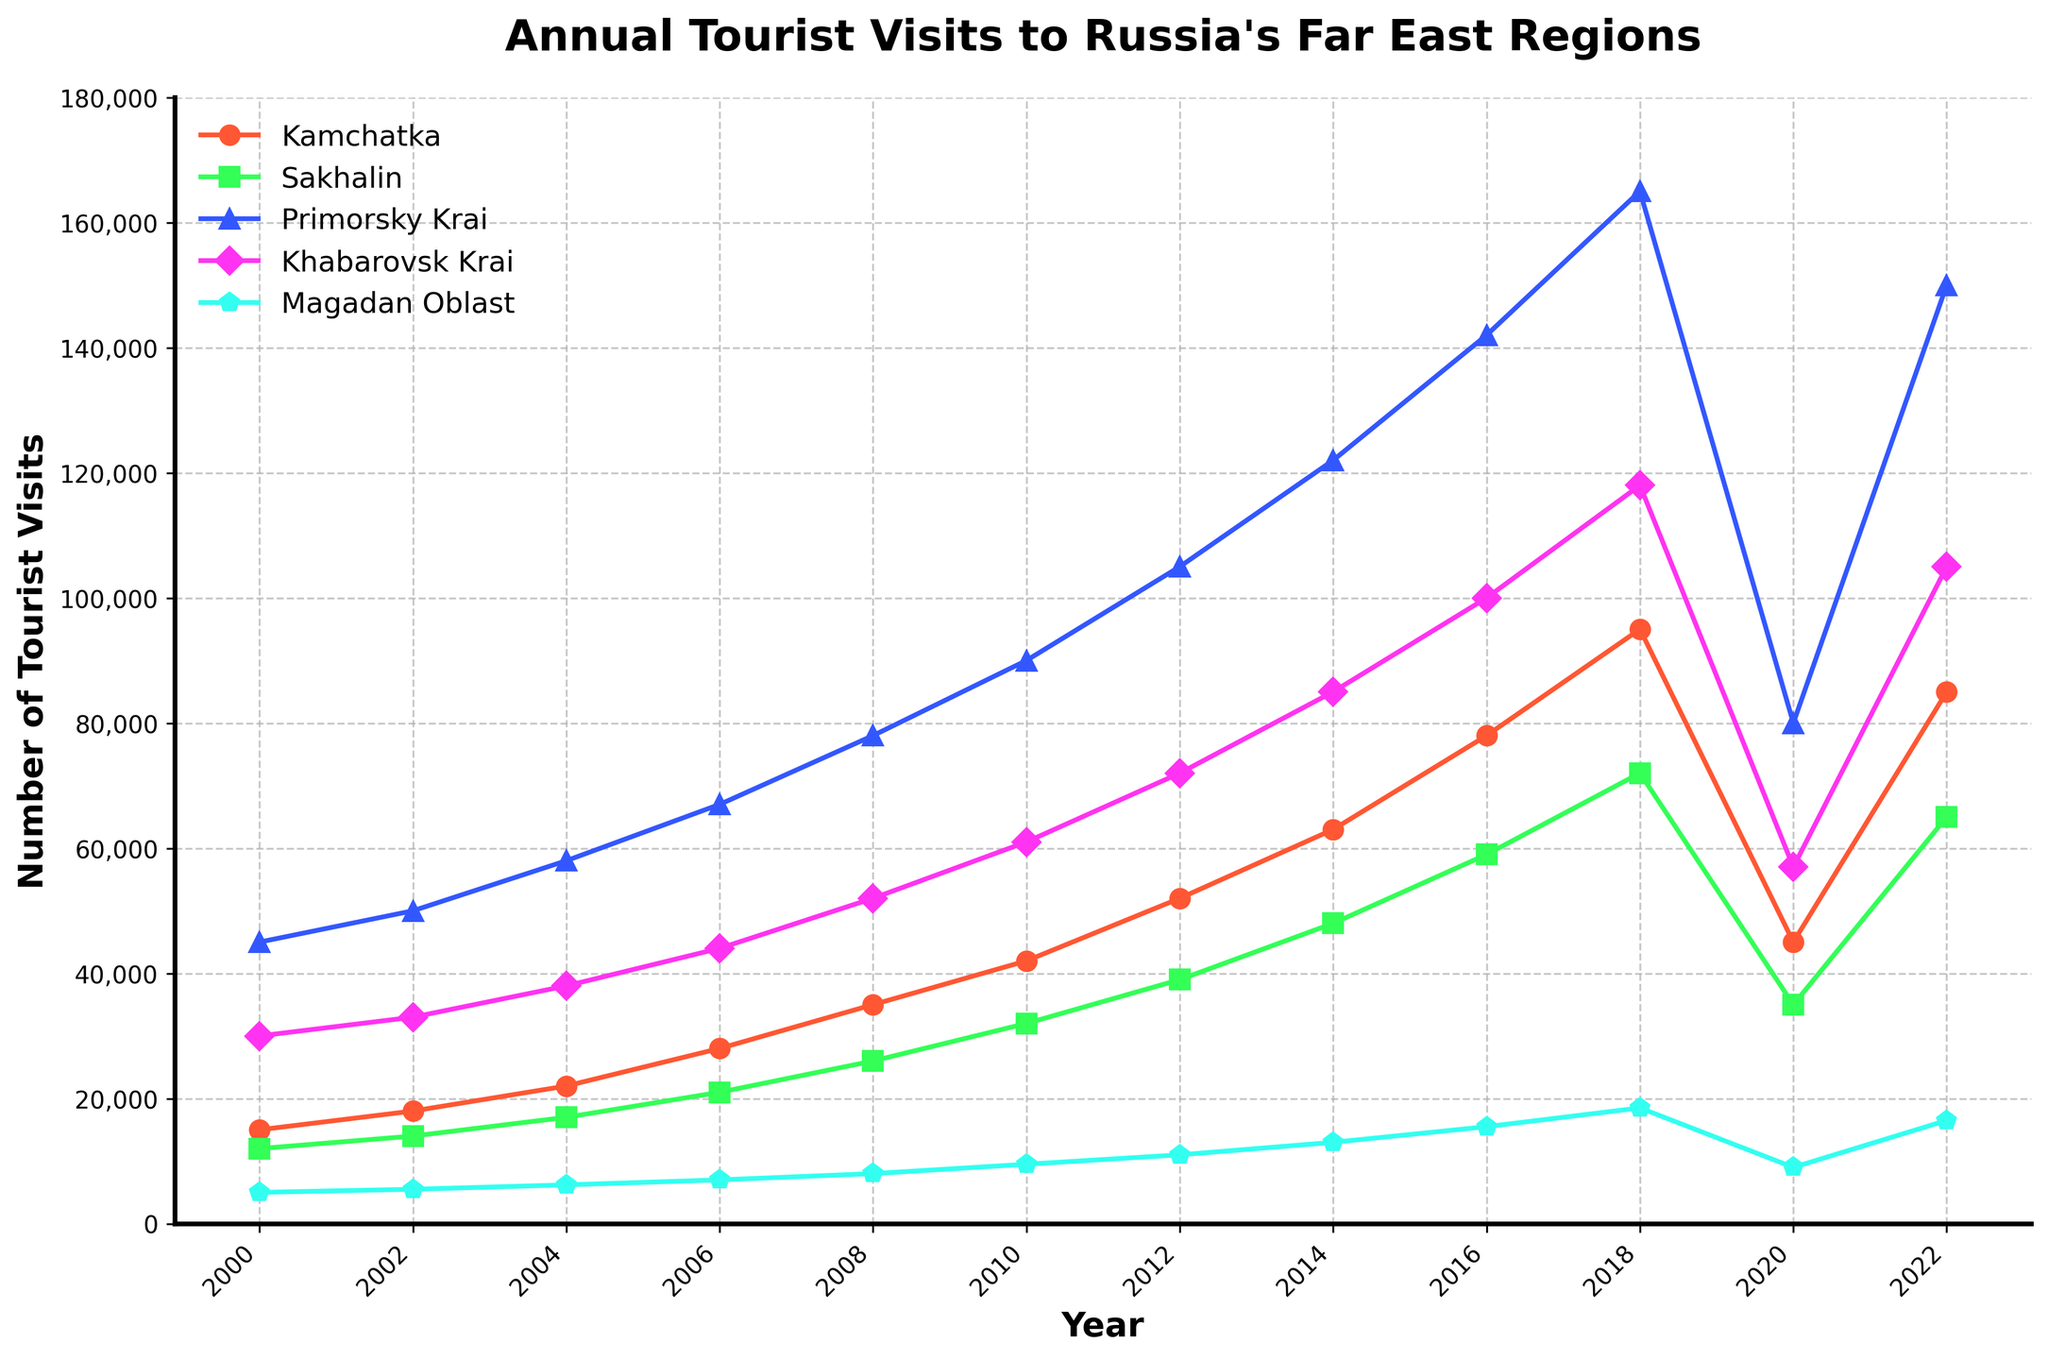What is the general trend of tourist visits to Kamchatka from 2000 to 2022? The trend of tourist visits to Kamchatka shows a consistent increase from 2000 to 2018. However, there is a notable drop in 2020, followed by a recovery in 2022. This can be seen from the rise and subsequent fall and rise of the line representing Kamchatka.
Answer: Consistent increase with a drop in 2020 and recovery in 2022 Compare the number of tourist visits to Primorsky Krai in 2010 and 2022. Looking at the plot, the number of tourist visits to Primorsky Krai in 2010 is 90,000, whereas, in 2022, it is 150,000. This indicates a significant increase.
Answer: 150,000 in 2022, 90,000 in 2010 Which region experienced the highest number of tourist visits in any given year? In 2018, Primorsky Krai had the highest number of tourist visits, reaching 165,000. This can be identified by observing the peak values across all regions on the plot.
Answer: Primorsky Krai in 2018 with 165,000 visits What is the average number of tourist visits to Sakhalin across the years provided? Sum the number of tourist visits to Sakhalin from 2000 to 2022 and then divide by the number of data points. (12000 + 14000 + 17000 + 21000 + 26000 + 32000 + 39000 + 48000 + 59000 + 72000 + 35000 + 65000) / 12 = 37600.
Answer: 37,600 Compare the trend of tourist visits between Khabarovsk Krai and Magadan Oblast. Both regions show an increasing trend from 2000 to 2018, followed by a drop in 2020 and a recovery in 2022. However, Khabarovsk Krai's numbers are consistently higher than Magadan Oblast's throughout the period.
Answer: Khabarovsk Krai consistently higher, similar trend What is the difference in tourist visits between Kamchatka and Sakhalin in 2006? In 2006, Kamchatka has 28,000 visits, and Sakhalin has 21,000 visits. The difference is 28,000 - 21,000 = 7,000.
Answer: 7,000 Identify the year with the lowest number of tourist visits to Magadan Oblast. Observing the plot, Magadan Oblast has the lowest number of tourist visits in 2000 with 5,000 visits.
Answer: 2000 with 5,000 visits How did the number of tourist visits to Primorsky Krai change between 2018 and 2020? In 2018, there were 165,000 visits to Primorsky Krai, and in 2020, this number dropped to 80,000. The change is 165,000 - 80,000 = 85,000.
Answer: Decreased by 85,000 Which year(s) did Kamchatka and Khabarovsk Krai have equal tourist visits? Analyzing the graph, Kamchatka and Khabarovsk Krai have equal tourist visits in no particular year; instead, Khabarovsk Krai consistently has more visitors.
Answer: None 